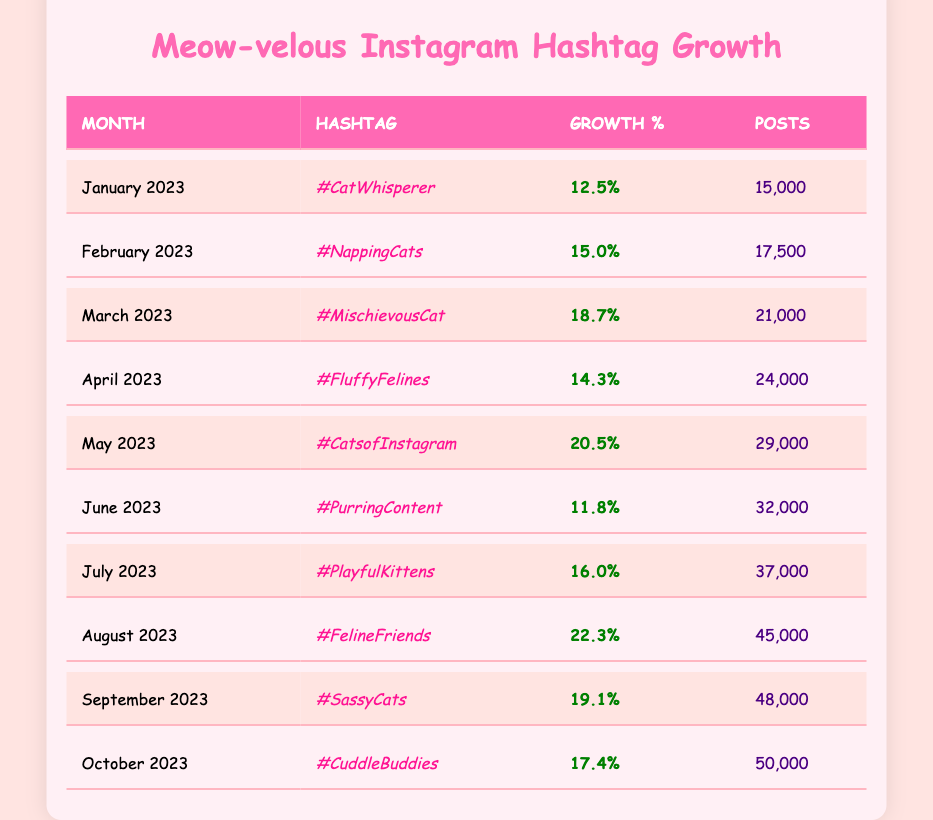What was the growth percentage for #FelineFriends in August 2023? The table shows that the growth percentage for #FelineFriends in August 2023 is listed as 22.3%.
Answer: 22.3% Which hashtag had the highest number of posts in October 2023? According to the table, the hashtag with the highest number of posts in October 2023 is #CuddleBuddies, with 50,000 posts.
Answer: #CuddleBuddies What was the average growth percentage over the year? To find the average, sum all the growth percentages: (12.5 + 15.0 + 18.7 + 14.3 + 20.5 + 11.8 + 16.0 + 22.3 + 19.1 + 17.4 =  16.91) and divide by the number of months (10) gives an average growth of 16.91%.
Answer: 16.91% Was there a month where the growth percentage was below 12%? By reviewing the table, April and June have growth percentages below 12%, specifically 14.3% and 11.8% respectively, meaning the statement is true.
Answer: Yes Which month saw the highest growth percentage and what was it? The highest growth percentage is noted for #FelineFriends in August 2023 with a 22.3% increase. After scanning through the table, August stands out as the month with the highest percentage.
Answer: August 2023, 22.3% How many more posts did #MischievousCat have in March 2023 compared to #NappingCats in February 2023? The number of posts for #MischievousCat in March 2023 is 21,000 and for #NappingCats in February 2023 is 17,500. By calculating the difference (21,000 - 17,500), we find there were 3,500 more posts for #MischievousCat.
Answer: 3,500 What percentage growth did #PurringContent have compared to #CatsofInstagram? The growth percentages are 11.8% for #PurringContent and 20.5% for #CatsofInstagram. The difference in growth percentages is 20.5% - 11.8% = 8.7%, indicating that #CatsofInstagram saw a higher growth by 8.7%.
Answer: 8.7% How many posts were there in total for the hashtags that reached 20% growth or higher? The hashtags that reached 20% growth or higher are #MischievousCat (21,000), #CatsofInstagram (29,000), and #FelineFriends (45,000). Adding these yields 21,000 + 29,000 + 45,000 = 95,000 posts.
Answer: 95,000 Is the growth for #SassyCats in September higher than the growth for #PlayfulKittens in July? The growth percentage for #SassyCats in September is 19.1%, while for #PlayfulKittens in July, it is 16.0%. Since 19.1% is greater than 16.0%, the statement is true.
Answer: Yes Which cat-related hashtag showed a consistent increase in posts every month? By reviewing the posts column month by month, we can see that each month's posts consistently increased, showing a growing trend. Therefore, all listed hashtags had a consistent increase in posts.
Answer: All hashtags showed an increase 